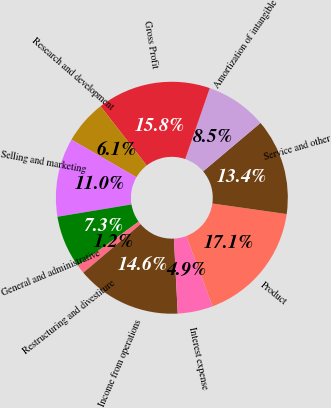Convert chart. <chart><loc_0><loc_0><loc_500><loc_500><pie_chart><fcel>Product<fcel>Service and other<fcel>Amortization of intangible<fcel>Gross Profit<fcel>Research and development<fcel>Selling and marketing<fcel>General and administrative<fcel>Restructuring and divestiture<fcel>Income from operations<fcel>Interest expense<nl><fcel>17.05%<fcel>13.4%<fcel>8.54%<fcel>15.84%<fcel>6.11%<fcel>10.97%<fcel>7.32%<fcel>1.24%<fcel>14.62%<fcel>4.89%<nl></chart> 